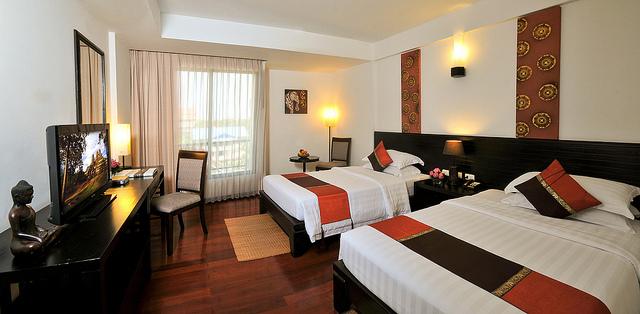Is the window opened?
Be succinct. No. How many beds?
Short answer required. 2. What shape is the artwork on the wall behind the bed?
Be succinct. Rectangle. 